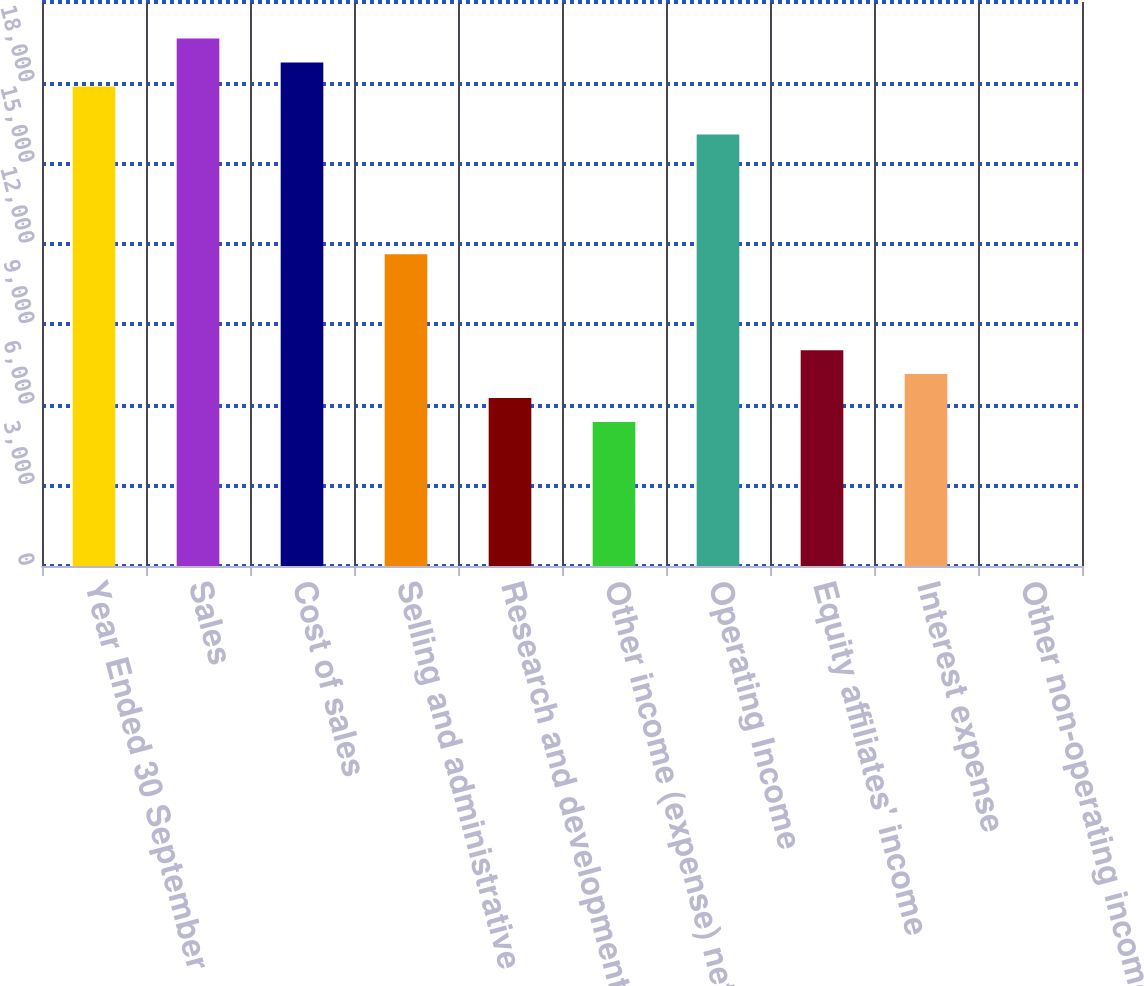Convert chart to OTSL. <chart><loc_0><loc_0><loc_500><loc_500><bar_chart><fcel>Year Ended 30 September<fcel>Sales<fcel>Cost of sales<fcel>Selling and administrative<fcel>Research and development<fcel>Other income (expense) net<fcel>Operating Income<fcel>Equity affiliates' income<fcel>Interest expense<fcel>Other non-operating income<nl><fcel>17855.3<fcel>19640.3<fcel>18747.8<fcel>11607.7<fcel>6252.67<fcel>5360.16<fcel>16070.3<fcel>8037.69<fcel>7145.18<fcel>5.1<nl></chart> 